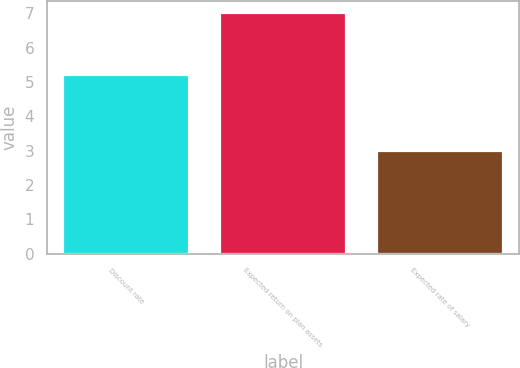Convert chart. <chart><loc_0><loc_0><loc_500><loc_500><bar_chart><fcel>Discount rate<fcel>Expected return on plan assets<fcel>Expected rate of salary<nl><fcel>5.2<fcel>7<fcel>3<nl></chart> 